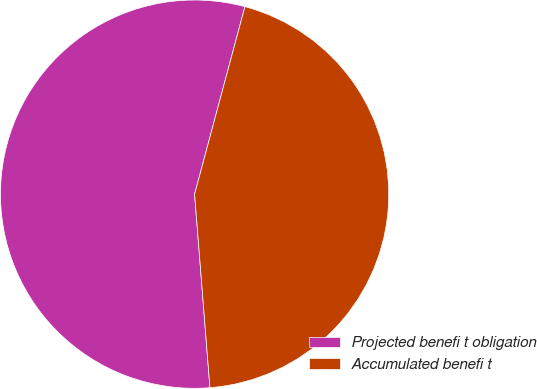Convert chart. <chart><loc_0><loc_0><loc_500><loc_500><pie_chart><fcel>Projected benefi t obligation<fcel>Accumulated benefi t<nl><fcel>55.43%<fcel>44.57%<nl></chart> 